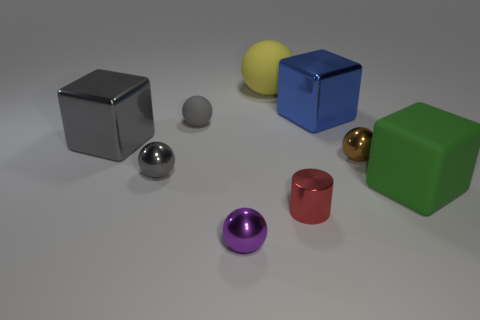What is the large object that is right of the red metallic cylinder and behind the green block made of?
Ensure brevity in your answer.  Metal. Are any brown metallic cylinders visible?
Ensure brevity in your answer.  No. There is a tiny matte sphere; is its color the same as the tiny ball that is in front of the big green rubber thing?
Your response must be concise. No. There is a block that is the same color as the tiny rubber ball; what is it made of?
Your answer should be compact. Metal. Is there anything else that is the same shape as the tiny purple thing?
Give a very brief answer. Yes. What is the shape of the big matte object left of the big cube in front of the small metallic thing to the left of the small purple metallic thing?
Provide a short and direct response. Sphere. What shape is the small gray metallic object?
Your response must be concise. Sphere. The metallic sphere in front of the big matte block is what color?
Provide a short and direct response. Purple. Does the shiny sphere on the right side of the cylinder have the same size as the large yellow matte ball?
Offer a terse response. No. The gray metal object that is the same shape as the large yellow rubber object is what size?
Provide a succinct answer. Small. 